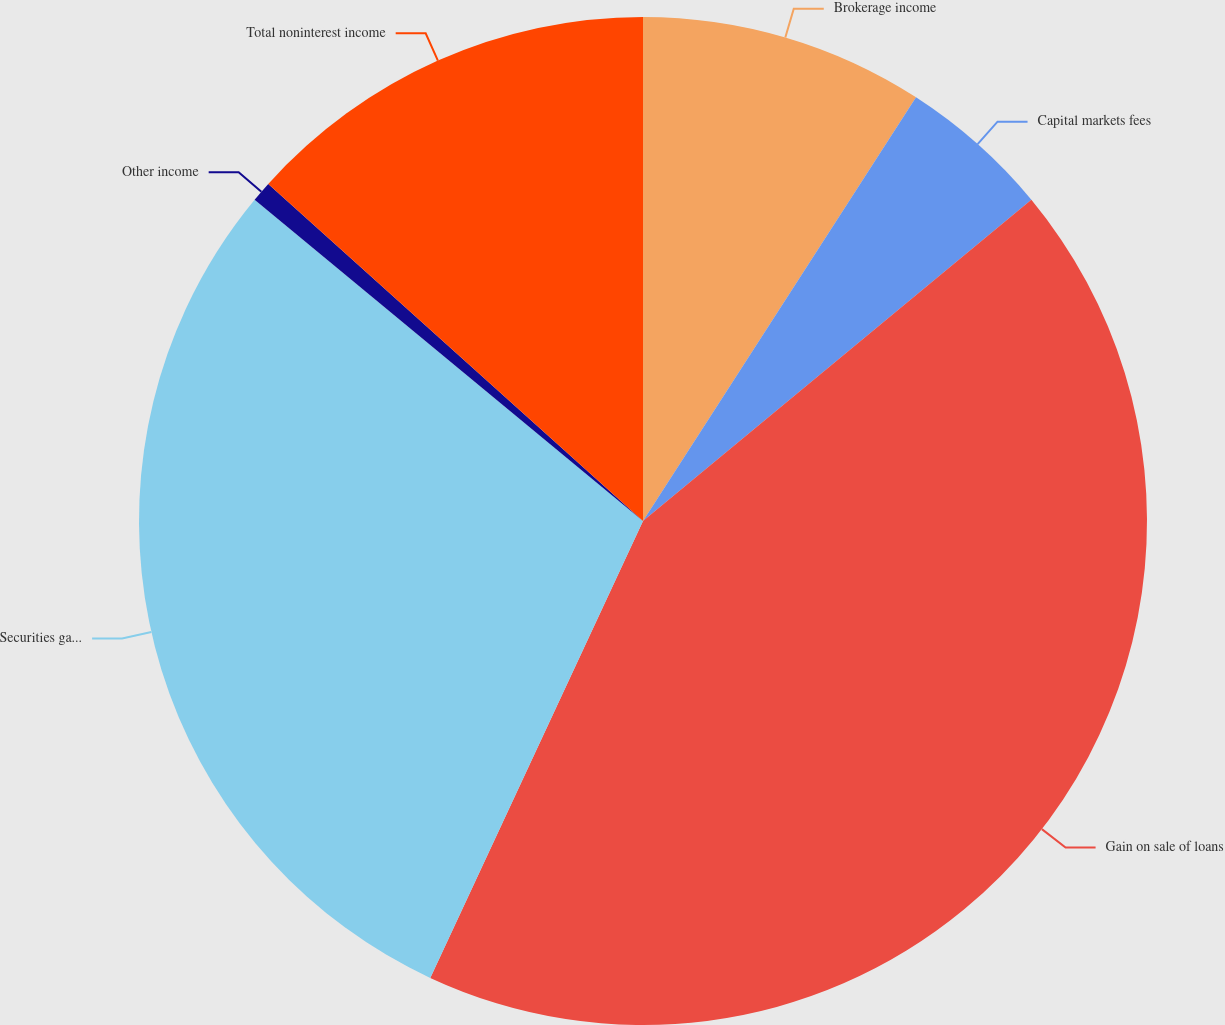Convert chart to OTSL. <chart><loc_0><loc_0><loc_500><loc_500><pie_chart><fcel>Brokerage income<fcel>Capital markets fees<fcel>Gain on sale of loans<fcel>Securities gains (losses)<fcel>Other income<fcel>Total noninterest income<nl><fcel>9.11%<fcel>4.89%<fcel>42.93%<fcel>29.06%<fcel>0.66%<fcel>13.34%<nl></chart> 